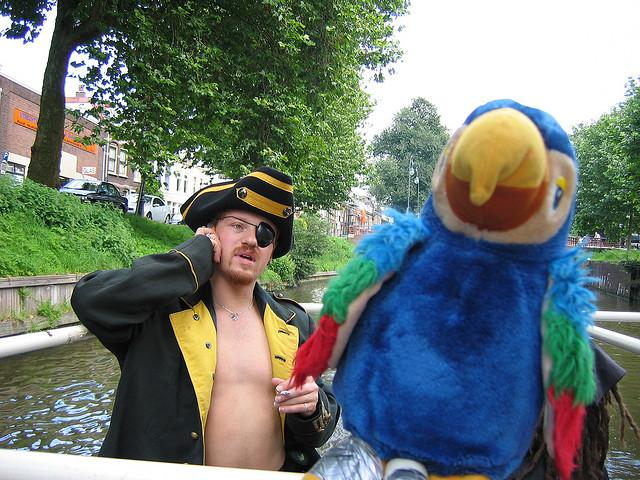What is the shirtless man dressed as? pirate 